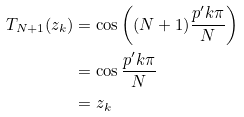<formula> <loc_0><loc_0><loc_500><loc_500>T _ { N + 1 } ( z _ { k } ) & = \cos \left ( ( N + 1 ) \frac { p ^ { \prime } k \pi } { N } \right ) \\ & = \cos \frac { p ^ { \prime } k \pi } { N } \\ & = z _ { k }</formula> 